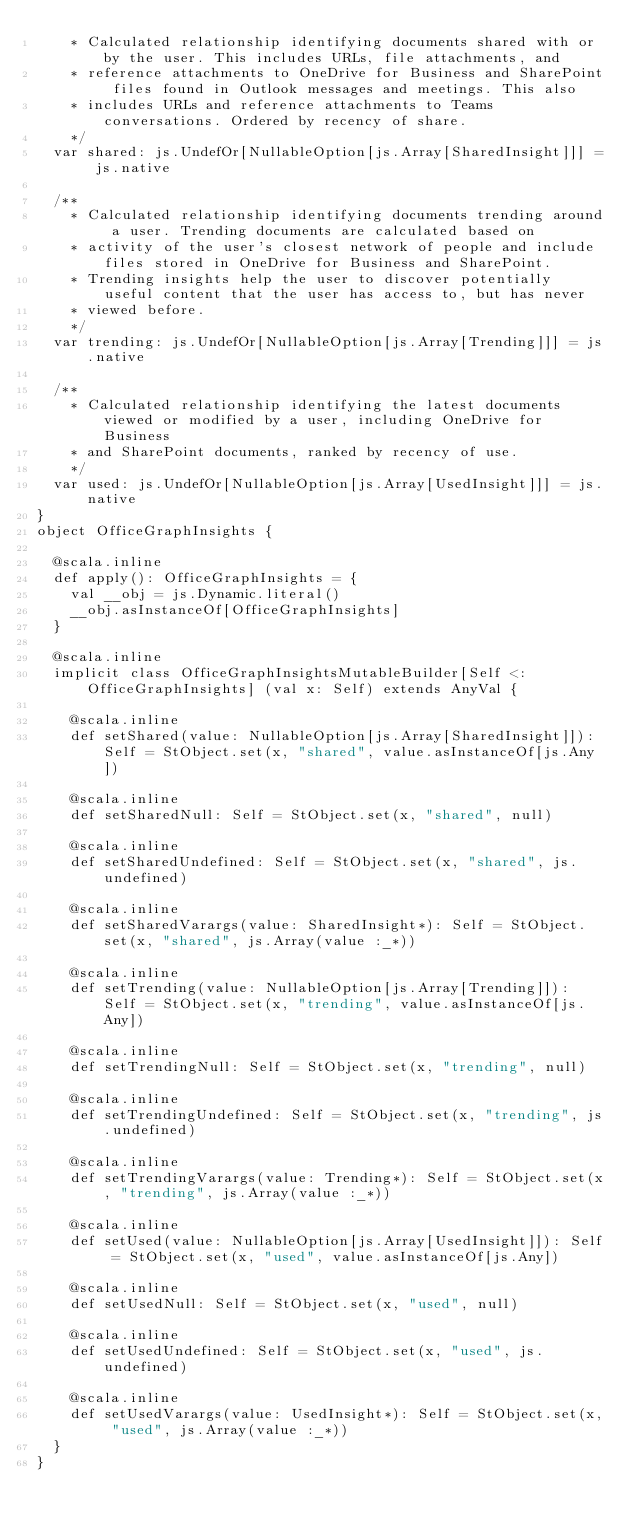Convert code to text. <code><loc_0><loc_0><loc_500><loc_500><_Scala_>    * Calculated relationship identifying documents shared with or by the user. This includes URLs, file attachments, and
    * reference attachments to OneDrive for Business and SharePoint files found in Outlook messages and meetings. This also
    * includes URLs and reference attachments to Teams conversations. Ordered by recency of share.
    */
  var shared: js.UndefOr[NullableOption[js.Array[SharedInsight]]] = js.native
  
  /**
    * Calculated relationship identifying documents trending around a user. Trending documents are calculated based on
    * activity of the user's closest network of people and include files stored in OneDrive for Business and SharePoint.
    * Trending insights help the user to discover potentially useful content that the user has access to, but has never
    * viewed before.
    */
  var trending: js.UndefOr[NullableOption[js.Array[Trending]]] = js.native
  
  /**
    * Calculated relationship identifying the latest documents viewed or modified by a user, including OneDrive for Business
    * and SharePoint documents, ranked by recency of use.
    */
  var used: js.UndefOr[NullableOption[js.Array[UsedInsight]]] = js.native
}
object OfficeGraphInsights {
  
  @scala.inline
  def apply(): OfficeGraphInsights = {
    val __obj = js.Dynamic.literal()
    __obj.asInstanceOf[OfficeGraphInsights]
  }
  
  @scala.inline
  implicit class OfficeGraphInsightsMutableBuilder[Self <: OfficeGraphInsights] (val x: Self) extends AnyVal {
    
    @scala.inline
    def setShared(value: NullableOption[js.Array[SharedInsight]]): Self = StObject.set(x, "shared", value.asInstanceOf[js.Any])
    
    @scala.inline
    def setSharedNull: Self = StObject.set(x, "shared", null)
    
    @scala.inline
    def setSharedUndefined: Self = StObject.set(x, "shared", js.undefined)
    
    @scala.inline
    def setSharedVarargs(value: SharedInsight*): Self = StObject.set(x, "shared", js.Array(value :_*))
    
    @scala.inline
    def setTrending(value: NullableOption[js.Array[Trending]]): Self = StObject.set(x, "trending", value.asInstanceOf[js.Any])
    
    @scala.inline
    def setTrendingNull: Self = StObject.set(x, "trending", null)
    
    @scala.inline
    def setTrendingUndefined: Self = StObject.set(x, "trending", js.undefined)
    
    @scala.inline
    def setTrendingVarargs(value: Trending*): Self = StObject.set(x, "trending", js.Array(value :_*))
    
    @scala.inline
    def setUsed(value: NullableOption[js.Array[UsedInsight]]): Self = StObject.set(x, "used", value.asInstanceOf[js.Any])
    
    @scala.inline
    def setUsedNull: Self = StObject.set(x, "used", null)
    
    @scala.inline
    def setUsedUndefined: Self = StObject.set(x, "used", js.undefined)
    
    @scala.inline
    def setUsedVarargs(value: UsedInsight*): Self = StObject.set(x, "used", js.Array(value :_*))
  }
}
</code> 